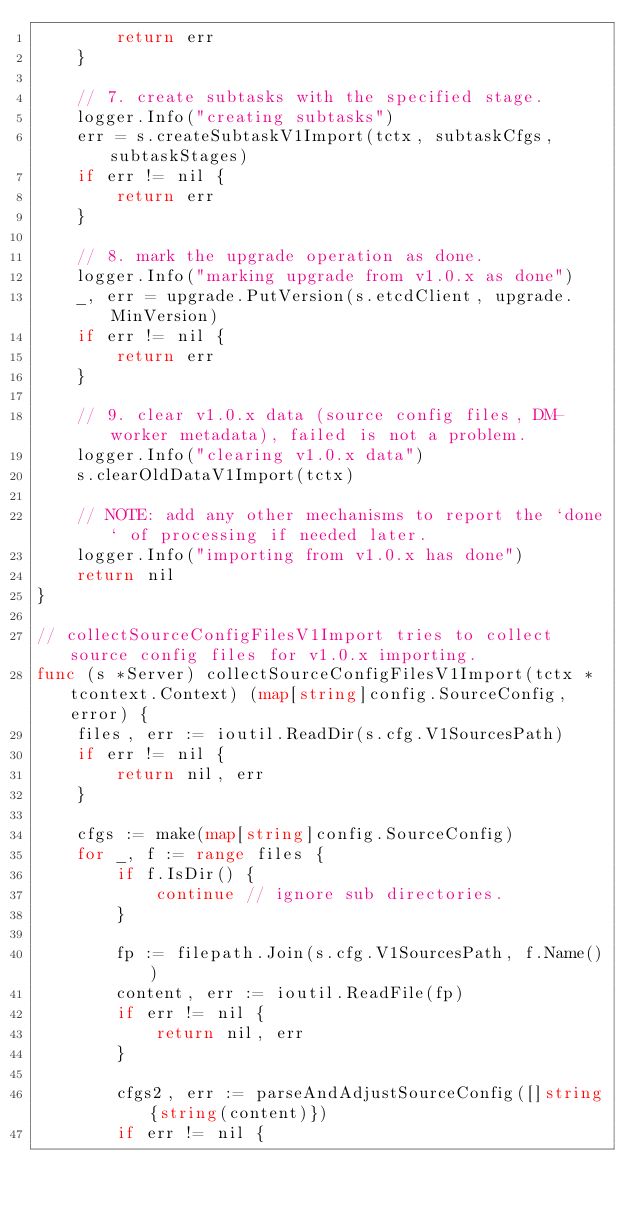Convert code to text. <code><loc_0><loc_0><loc_500><loc_500><_Go_>		return err
	}

	// 7. create subtasks with the specified stage.
	logger.Info("creating subtasks")
	err = s.createSubtaskV1Import(tctx, subtaskCfgs, subtaskStages)
	if err != nil {
		return err
	}

	// 8. mark the upgrade operation as done.
	logger.Info("marking upgrade from v1.0.x as done")
	_, err = upgrade.PutVersion(s.etcdClient, upgrade.MinVersion)
	if err != nil {
		return err
	}

	// 9. clear v1.0.x data (source config files, DM-worker metadata), failed is not a problem.
	logger.Info("clearing v1.0.x data")
	s.clearOldDataV1Import(tctx)

	// NOTE: add any other mechanisms to report the `done` of processing if needed later.
	logger.Info("importing from v1.0.x has done")
	return nil
}

// collectSourceConfigFilesV1Import tries to collect source config files for v1.0.x importing.
func (s *Server) collectSourceConfigFilesV1Import(tctx *tcontext.Context) (map[string]config.SourceConfig, error) {
	files, err := ioutil.ReadDir(s.cfg.V1SourcesPath)
	if err != nil {
		return nil, err
	}

	cfgs := make(map[string]config.SourceConfig)
	for _, f := range files {
		if f.IsDir() {
			continue // ignore sub directories.
		}

		fp := filepath.Join(s.cfg.V1SourcesPath, f.Name())
		content, err := ioutil.ReadFile(fp)
		if err != nil {
			return nil, err
		}

		cfgs2, err := parseAndAdjustSourceConfig([]string{string(content)})
		if err != nil {</code> 